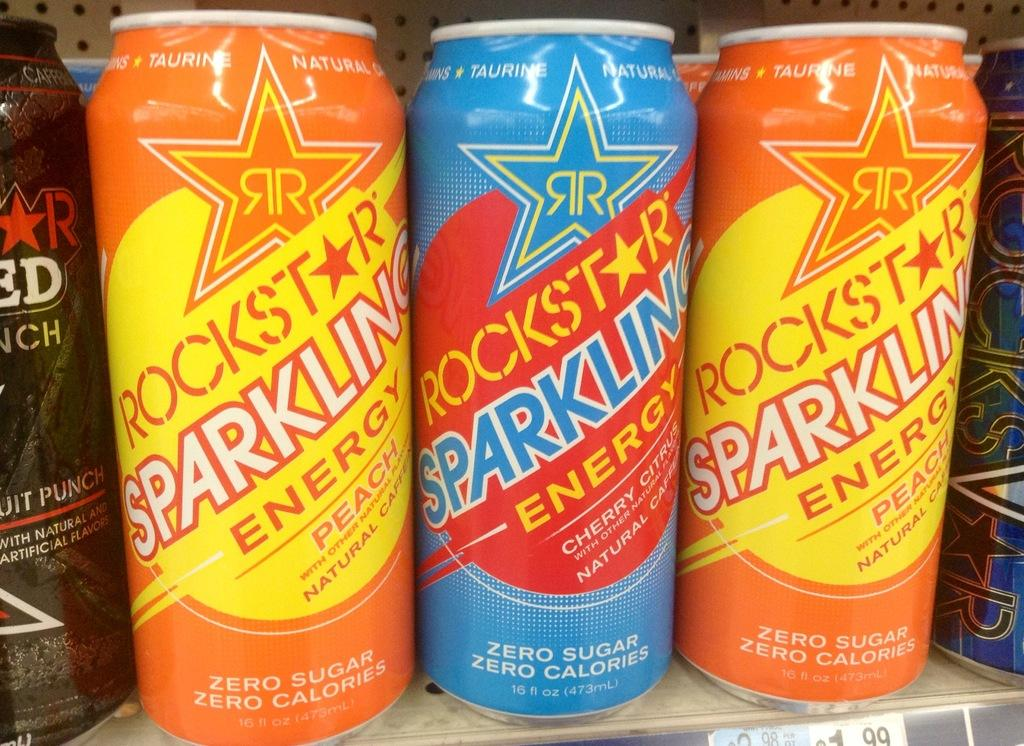Provide a one-sentence caption for the provided image. A row of energy drinks that say Rockstar Sparkling Energy. 